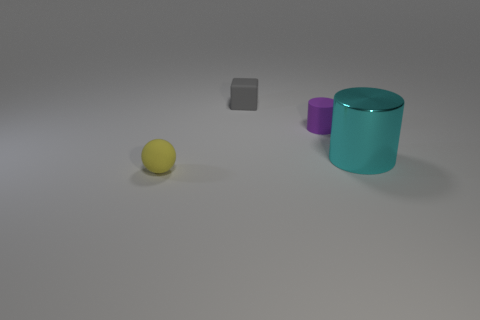How does the lighting in the image affect the appearance of the objects? The diffuse lighting in the image gives the objects a soft shadow, contributing to a calm and balanced composition. It highlights the objects' textures and their reflective qualities, allowing each item to stand out distinctly against the neutral background. 